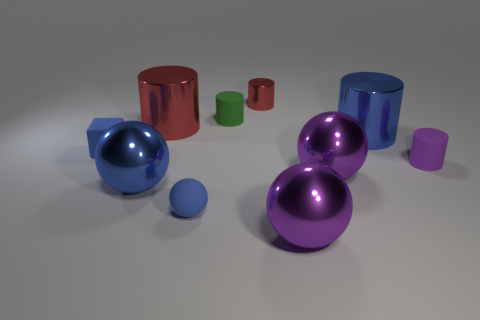How many objects are tiny green cylinders or small objects in front of the blue cylinder?
Offer a terse response. 4. How many tiny blue matte things are there?
Offer a terse response. 2. Is there a purple thing that has the same size as the green rubber cylinder?
Provide a succinct answer. Yes. Are there fewer tiny green matte things that are behind the tiny green rubber thing than blue objects?
Your answer should be compact. Yes. Is the block the same size as the blue metallic sphere?
Offer a very short reply. No. There is a blue ball that is made of the same material as the tiny green thing; what size is it?
Your answer should be compact. Small. How many large metallic things are the same color as the matte sphere?
Give a very brief answer. 2. Is the number of small cylinders that are left of the small green matte thing less than the number of shiny things in front of the purple matte object?
Ensure brevity in your answer.  Yes. There is a big blue thing on the left side of the blue metallic cylinder; is its shape the same as the green object?
Ensure brevity in your answer.  No. Is the material of the large cylinder on the right side of the big red cylinder the same as the small purple object?
Keep it short and to the point. No. 